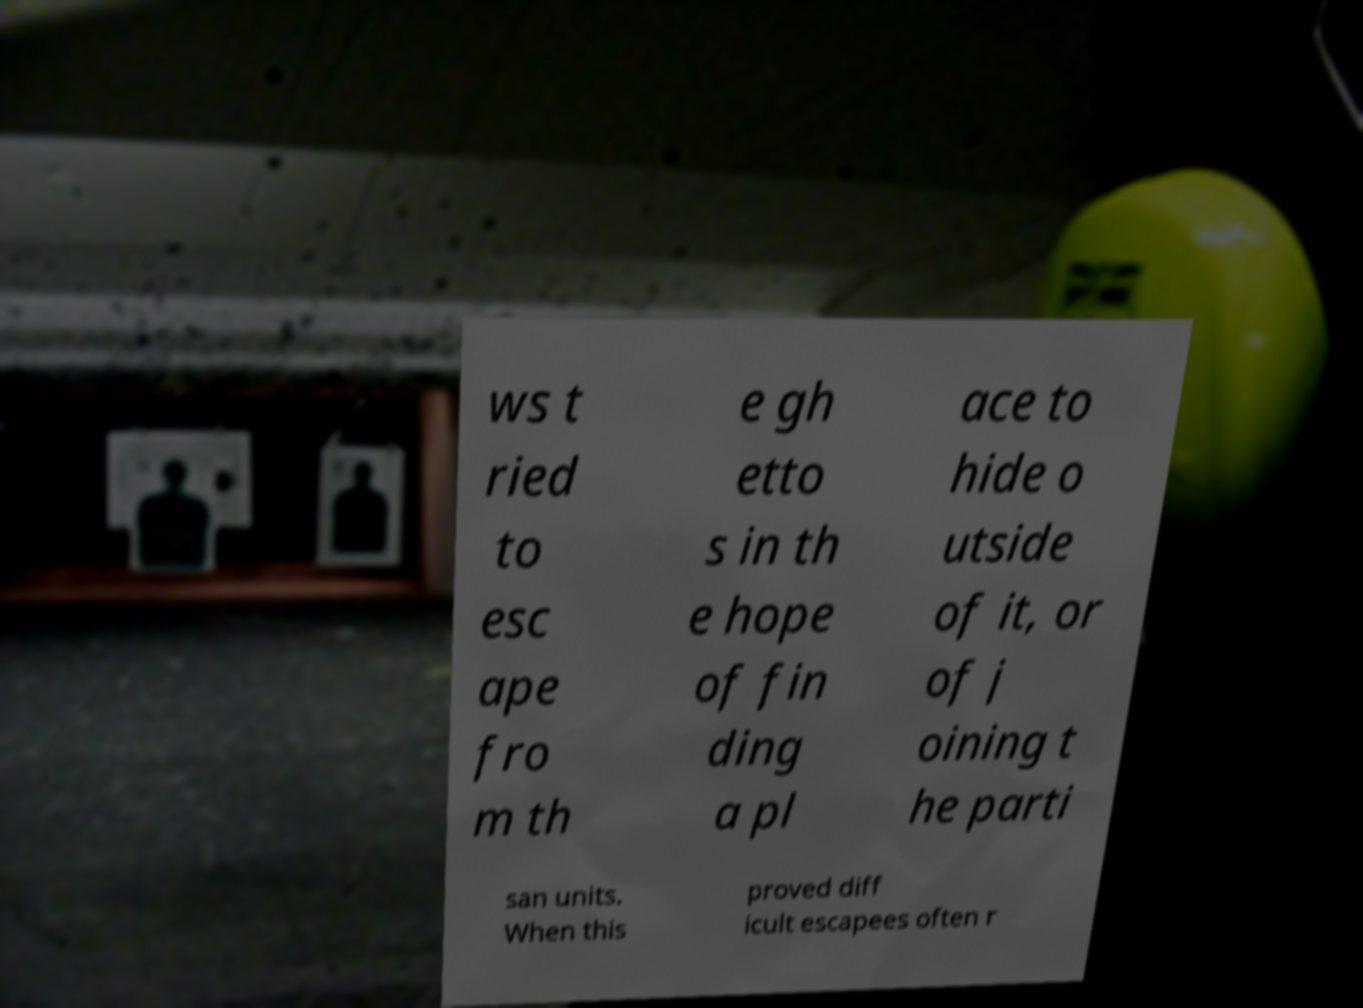Please identify and transcribe the text found in this image. ws t ried to esc ape fro m th e gh etto s in th e hope of fin ding a pl ace to hide o utside of it, or of j oining t he parti san units. When this proved diff icult escapees often r 